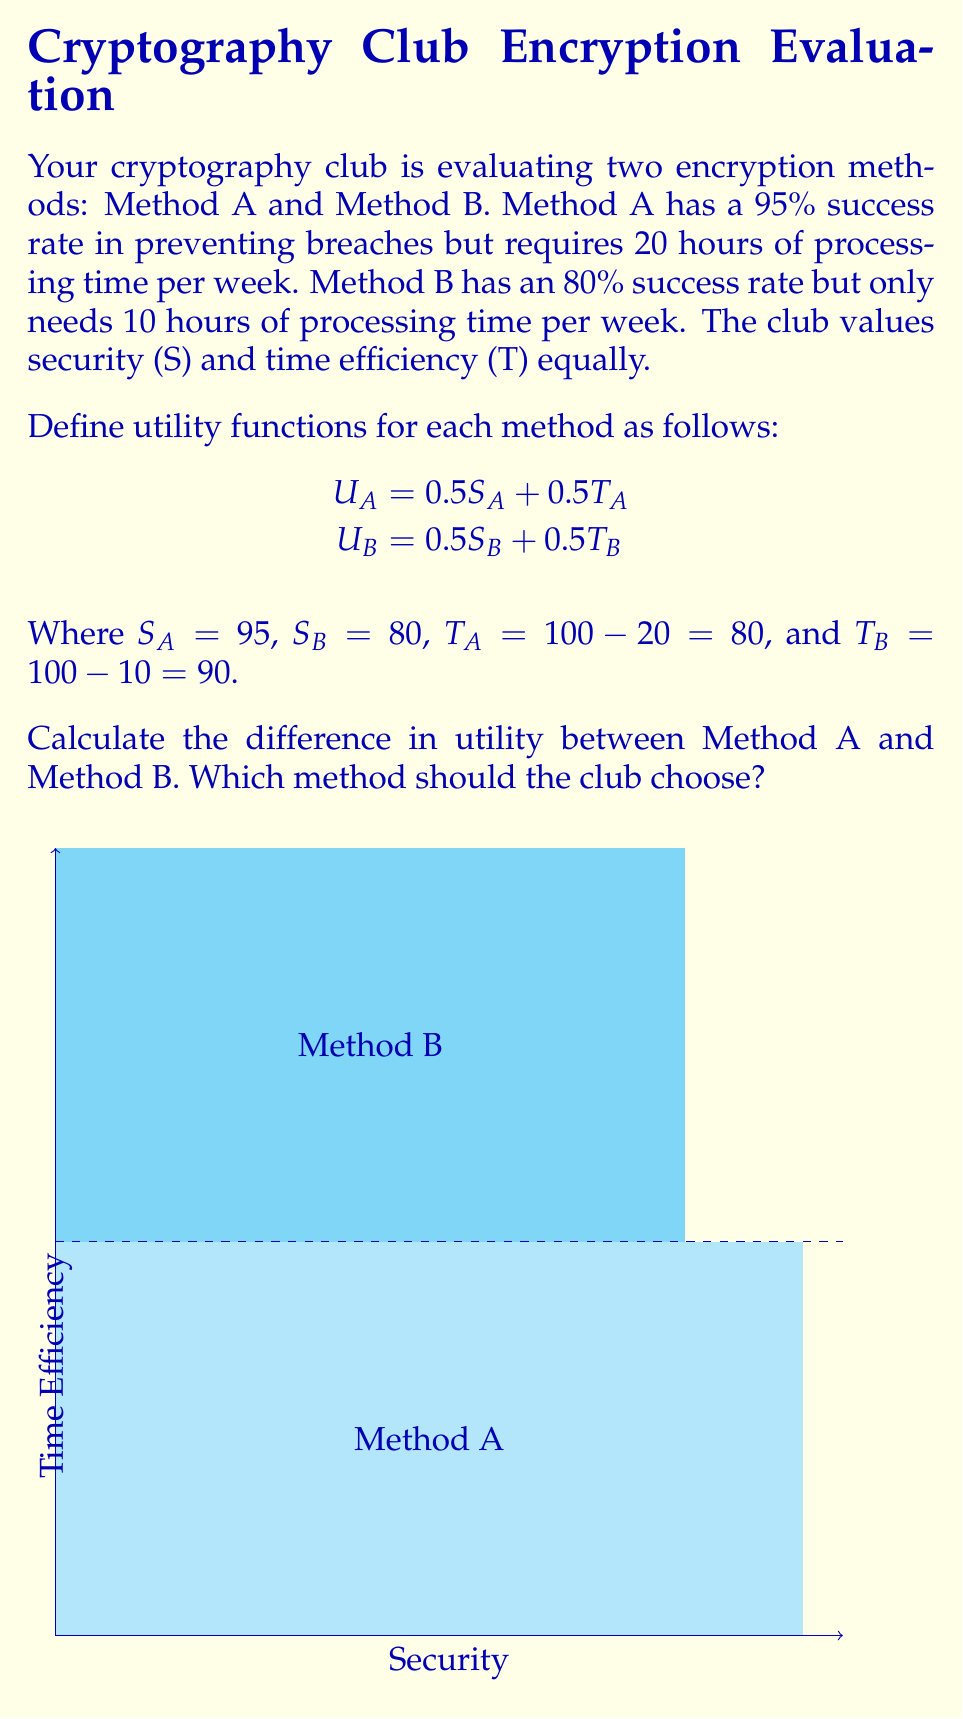Provide a solution to this math problem. Let's approach this step-by-step:

1) First, let's calculate the utility for Method A:
   $$U_A = 0.5S_A + 0.5T_A = 0.5(95) + 0.5(80) = 47.5 + 40 = 87.5$$

2) Now, let's calculate the utility for Method B:
   $$U_B = 0.5S_B + 0.5T_B = 0.5(80) + 0.5(90) = 40 + 45 = 85$$

3) To find the difference in utility, we subtract:
   $$U_A - U_B = 87.5 - 85 = 2.5$$

4) Since the difference is positive, Method A has a higher utility.

5) To determine which method the club should choose, we compare the utilities:
   Since $U_A > U_B$, the club should choose Method A.

The difference of 2.5 in utility indicates that Method A is slightly more favorable when considering both security and time efficiency equally.
Answer: Utility difference: 2.5. Choose Method A. 